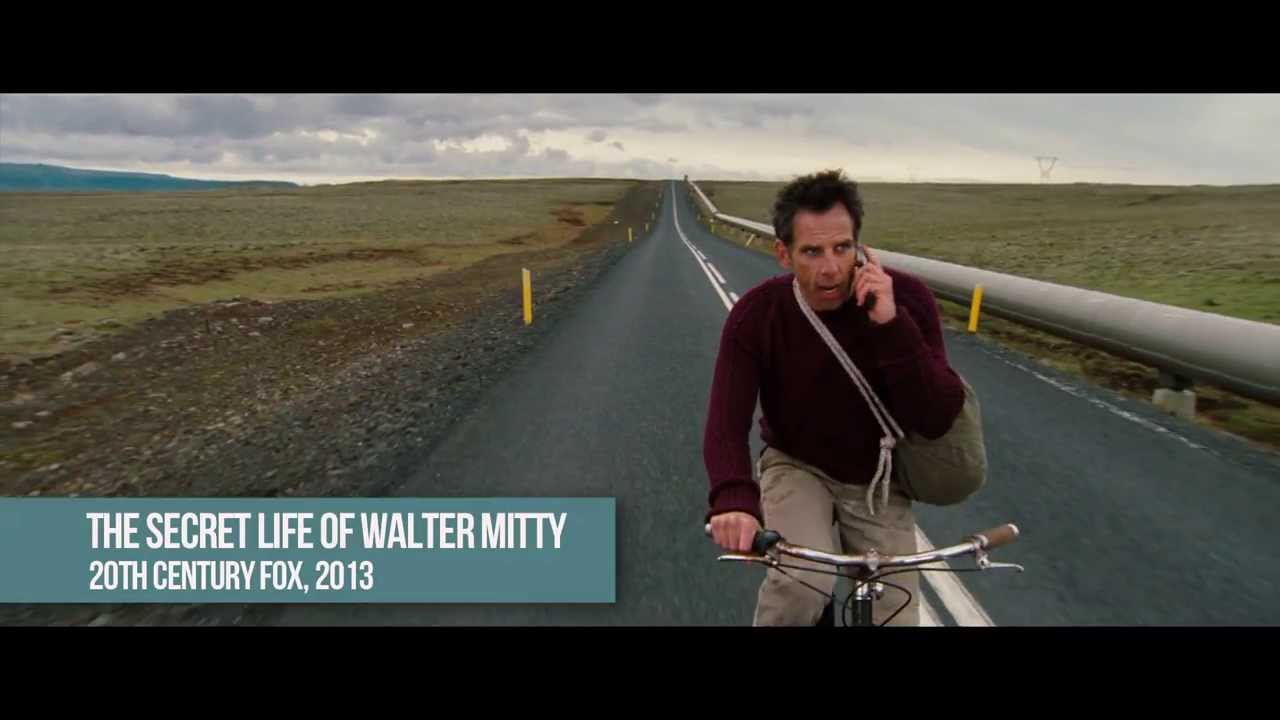Explain the visual content of the image in great detail. In this image, we see an actor riding a bicycle along a long, straight road that stretches into the horizon. The road is flanked by barren, desolate landscape with no significant features, creating a feeling of isolation and vastness. The sky is overcast with clouds, adding a somber and contemplative mood to the scene. The actor, clad in a maroon sweater and light-colored pants, appears to be pedaling with a sense of urgency or worry, as indicated by his serious expression and the fact that he is talking on a cellphone. The overall color palette of the image is dominated by muted grays, blues, and earth tones, further emphasizing the melancholic and introspective atmosphere. Additionally, the actor carrying a bag slung across his body gives a sense of a journey, reinforcing the themes of adventure and self-discovery. 